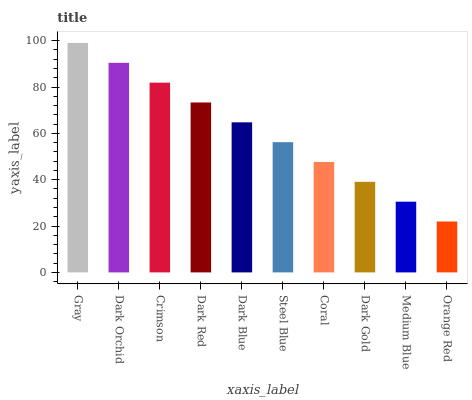Is Dark Orchid the minimum?
Answer yes or no. No. Is Dark Orchid the maximum?
Answer yes or no. No. Is Gray greater than Dark Orchid?
Answer yes or no. Yes. Is Dark Orchid less than Gray?
Answer yes or no. Yes. Is Dark Orchid greater than Gray?
Answer yes or no. No. Is Gray less than Dark Orchid?
Answer yes or no. No. Is Dark Blue the high median?
Answer yes or no. Yes. Is Steel Blue the low median?
Answer yes or no. Yes. Is Coral the high median?
Answer yes or no. No. Is Dark Blue the low median?
Answer yes or no. No. 